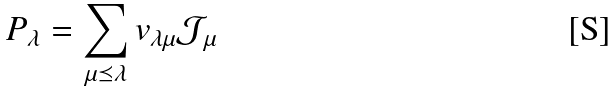<formula> <loc_0><loc_0><loc_500><loc_500>P _ { \lambda } = \sum _ { \mu \preceq \lambda } v _ { \lambda \mu } \mathcal { J } _ { \mu }</formula> 